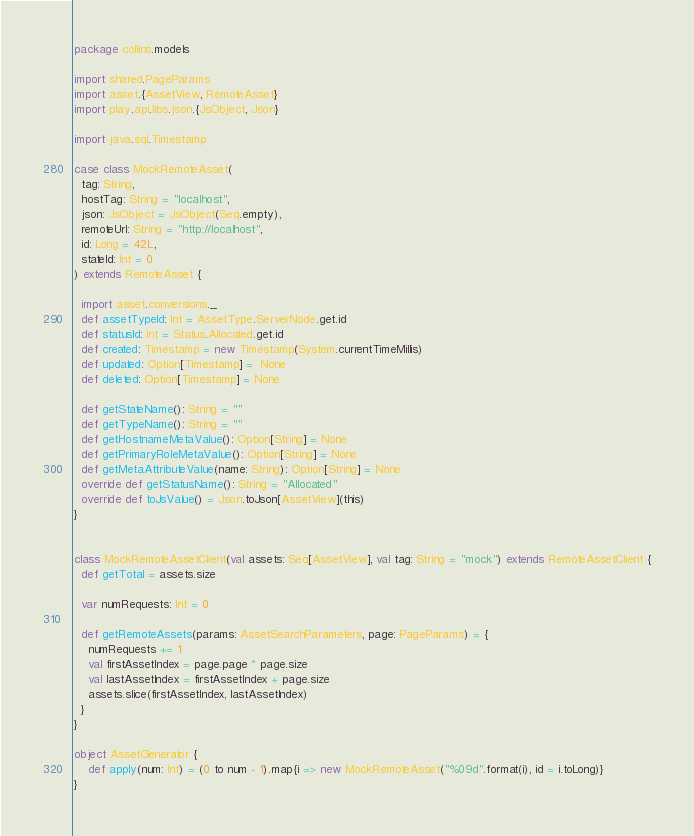Convert code to text. <code><loc_0><loc_0><loc_500><loc_500><_Scala_>package collins.models

import shared.PageParams
import asset.{AssetView, RemoteAsset}
import play.api.libs.json.{JsObject, Json}

import java.sql.Timestamp
 
case class MockRemoteAsset( 
  tag: String, 
  hostTag: String = "localhost", 
  json: JsObject = JsObject(Seq.empty),  
  remoteUrl: String = "http://localhost",
  id: Long = 42L,
  stateId: Int = 0
) extends RemoteAsset { 

  import asset.conversions._
  def assetTypeId: Int = AssetType.ServerNode.get.id
  def statusId: Int = Status.Allocated.get.id
  def created: Timestamp = new Timestamp(System.currentTimeMillis) 
  def updated: Option[Timestamp] =  None 
  def deleted: Option[Timestamp] = None
 
  def getStateName(): String = ""
  def getTypeName(): String = ""
  def getHostnameMetaValue(): Option[String] = None 
  def getPrimaryRoleMetaValue(): Option[String] = None 
  def getMetaAttributeValue(name: String): Option[String] = None
  override def getStatusName(): String = "Allocated"
  override def toJsValue() = Json.toJson[AssetView](this)
} 


class MockRemoteAssetClient(val assets: Seq[AssetView], val tag: String = "mock") extends RemoteAssetClient {
  def getTotal = assets.size

  var numRequests: Int = 0

  def getRemoteAssets(params: AssetSearchParameters, page: PageParams) = {
    numRequests += 1
    val firstAssetIndex = page.page * page.size
    val lastAssetIndex = firstAssetIndex + page.size
    assets.slice(firstAssetIndex, lastAssetIndex)
  }
}   
    
object AssetGenerator {
    def apply(num: Int) = (0 to num - 1).map{i => new MockRemoteAsset("%09d".format(i), id = i.toLong)}
}
</code> 